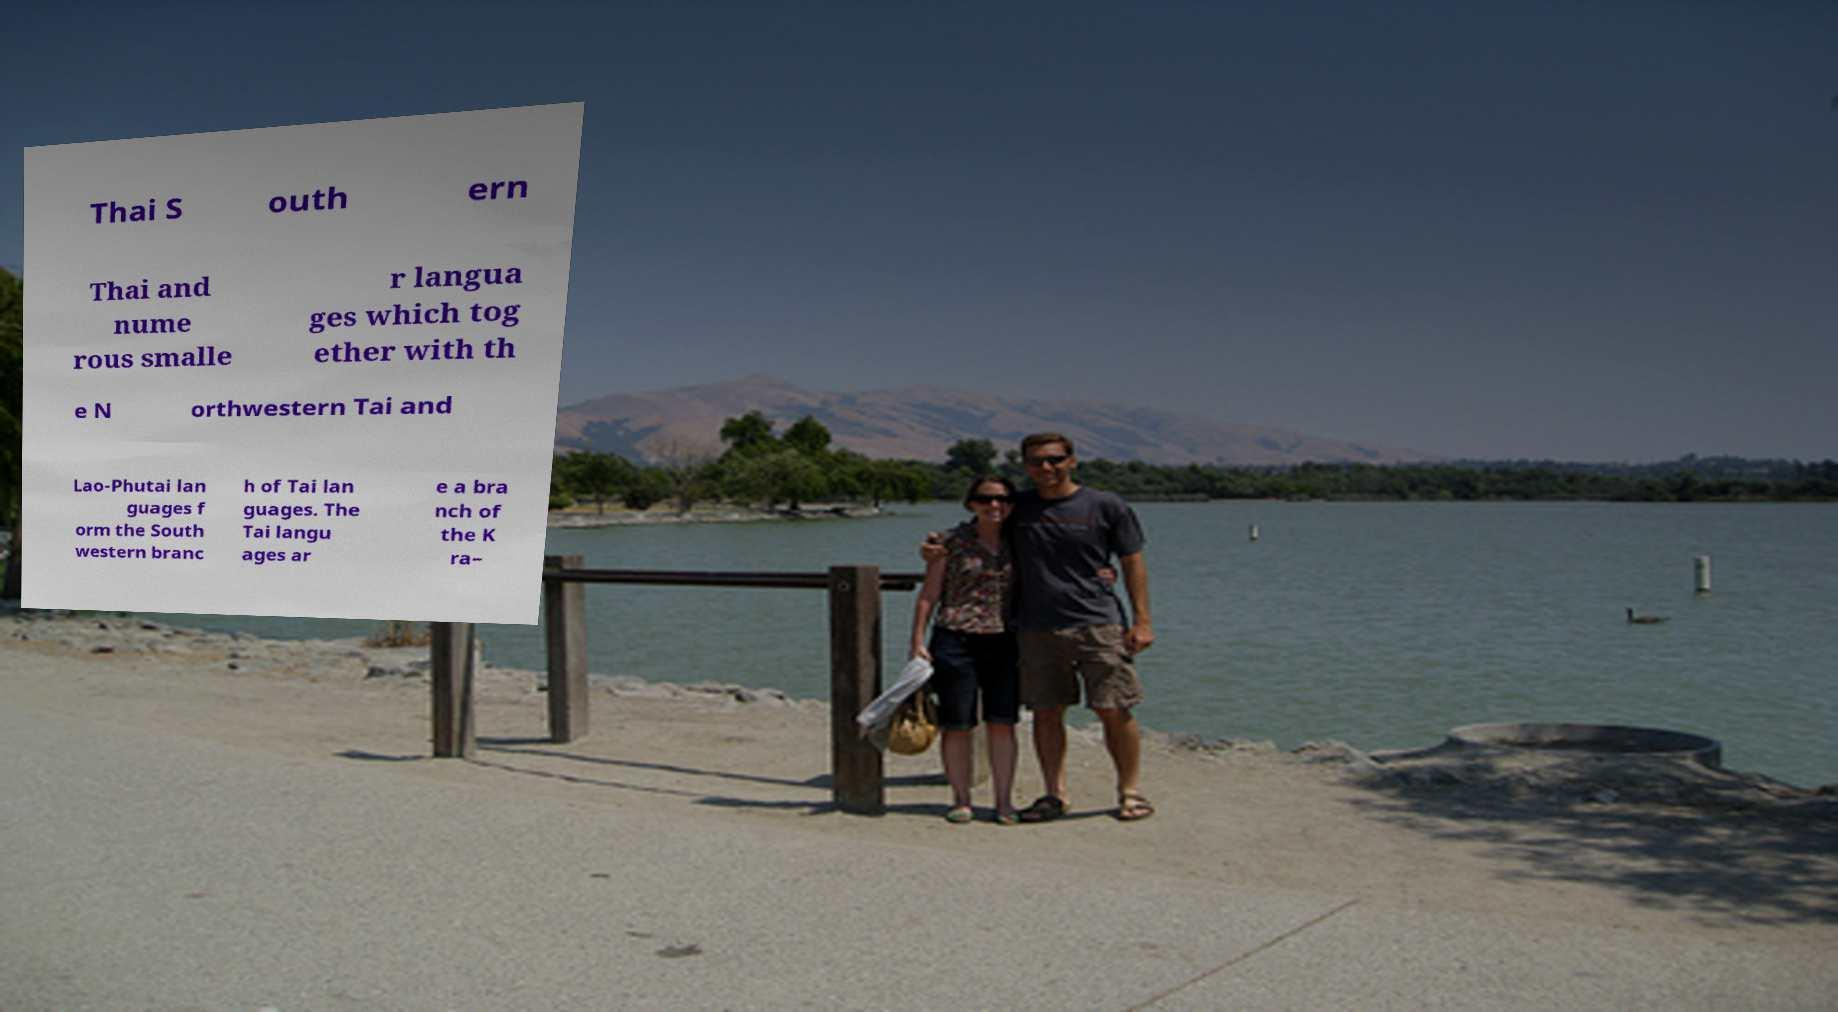Could you assist in decoding the text presented in this image and type it out clearly? Thai S outh ern Thai and nume rous smalle r langua ges which tog ether with th e N orthwestern Tai and Lao-Phutai lan guages f orm the South western branc h of Tai lan guages. The Tai langu ages ar e a bra nch of the K ra– 